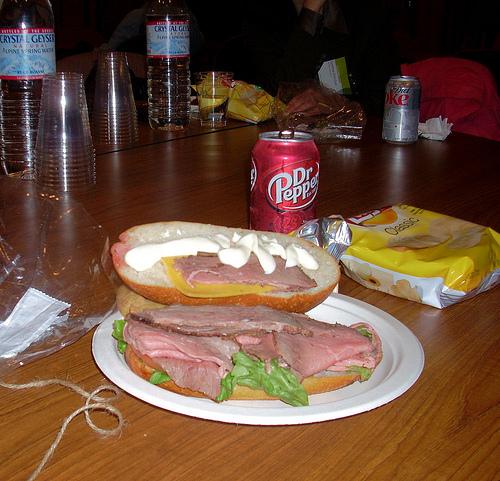Would a vegetarian eat this?
Quick response, please. No. What kind of soda is this?
Answer briefly. Dr pepper. What is the white stuff on the top bun?
Be succinct. Mayonnaise. 